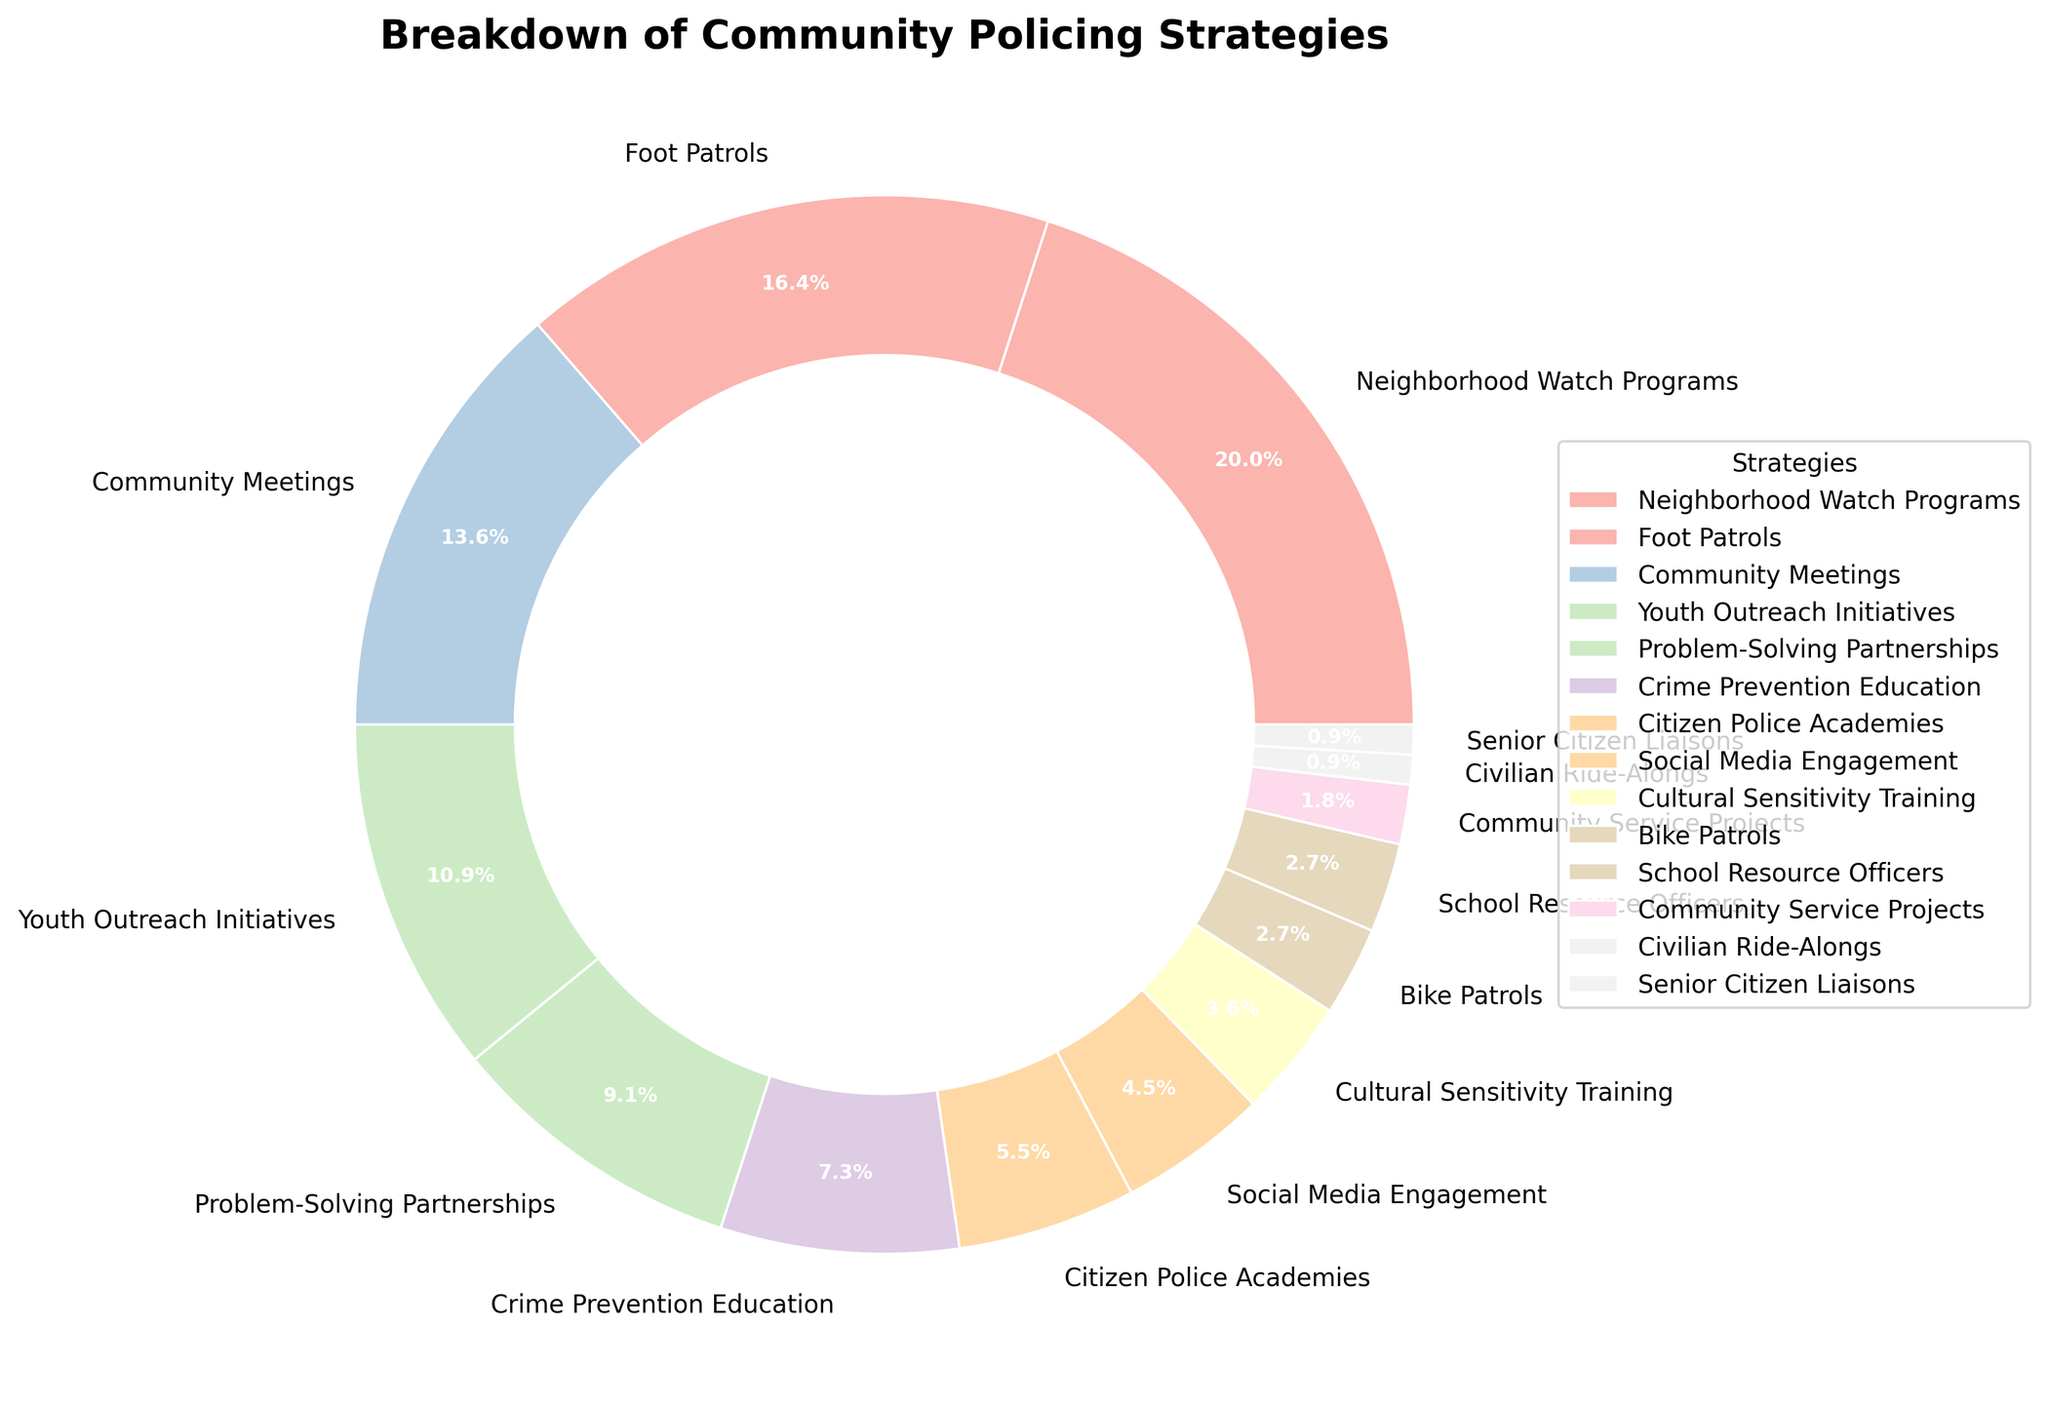Which strategy has the highest percentage in the breakdown of community policing strategies? The strategy with the largest portion of the pie chart is Neighborhood Watch Programs, indicated by the size of its segment.
Answer: Neighborhood Watch Programs What is the combined percentage of Foot Patrols and Community Meetings? Add the percentages of Foot Patrols (18%) and Community Meetings (15%). The combined percentage is 18% + 15% = 33%.
Answer: 33% Which strategy accounts for less than 5% of the total strategies implemented? Strategies with less than 5% are Social Media Engagement (5%), Cultural Sensitivity Training (4%), Bike Patrols (3%), School Resource Officers (3%), Community Service Projects (2%), Civilian Ride-Alongs (1%), and Senior Citizen Liaisons (1%).
Answer: Multiple strategies What percentage of the strategies are related to direct community engagement (sum of Youth Outreach Initiatives, Community Meetings, and Neighborhood Watch Programs)? Add the percentages of Youth Outreach Initiatives (12%), Community Meetings (15%), and Neighborhood Watch Programs (22%). The total is 12% + 15% + 22% = 49%.
Answer: 49% Compare the segment sizes for Crime Prevention Education and Problem-Solving Partnerships. Which one is larger and by how much? The segment for Crime Prevention Education is 8%, and the segment for Problem-Solving Partnerships is 10%. Therefore, Problem-Solving Partnerships is larger by 10% - 8% = 2%.
Answer: Problem-Solving Partnerships by 2% What is the median percentage value of all the strategies listed? Sort the percentages: [1, 1, 2, 3, 3, 4, 5, 6, 8, 10, 12, 15, 18, 22]. The median is the average of the two middle values (5 and 6) because there are 14 values. The median is (5 + 6) / 2 = 5.5%.
Answer: 5.5% Which strategy is represented by the narrowest segment in the pie chart? The strategy with the smallest percentage is represented by the narrowest segment, which is Civilian Ride-Alongs and Senior Citizen Liaisons, both at 1%.
Answer: Civilian Ride-Alongs and Senior Citizen Liaisons What is the difference in percentage between the largest and the smallest segments? The largest segment is Neighborhood Watch Programs (22%) and the smallest segments are Civilian Ride-Alongs and Senior Citizen Liaisons (1%). The difference is 22% - 1% = 21%.
Answer: 21% Which strategies together account for more than half of the total percentage? Note the strategies with significant percentages and sum them until the total exceeds 50%. Adding Neighborhood Watch Programs (22%), Foot Patrols (18%), Community Meetings (15%) together, we get 22% + 18% + 15% = 55%.
Answer: Neighborhood Watch Programs, Foot Patrols, and Community Meetings What percentage of strategies involve direct interaction with citizens (sum of Foot Patrols and Community Service Projects)? Add the percentages of Foot Patrols (18%) and Community Service Projects (2%). The total is 18% + 2% = 20%.
Answer: 20% 